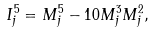<formula> <loc_0><loc_0><loc_500><loc_500>I ^ { 5 } _ { j } = M ^ { 5 } _ { j } - 1 0 M ^ { 3 } _ { j } M ^ { 2 } _ { j } ,</formula> 